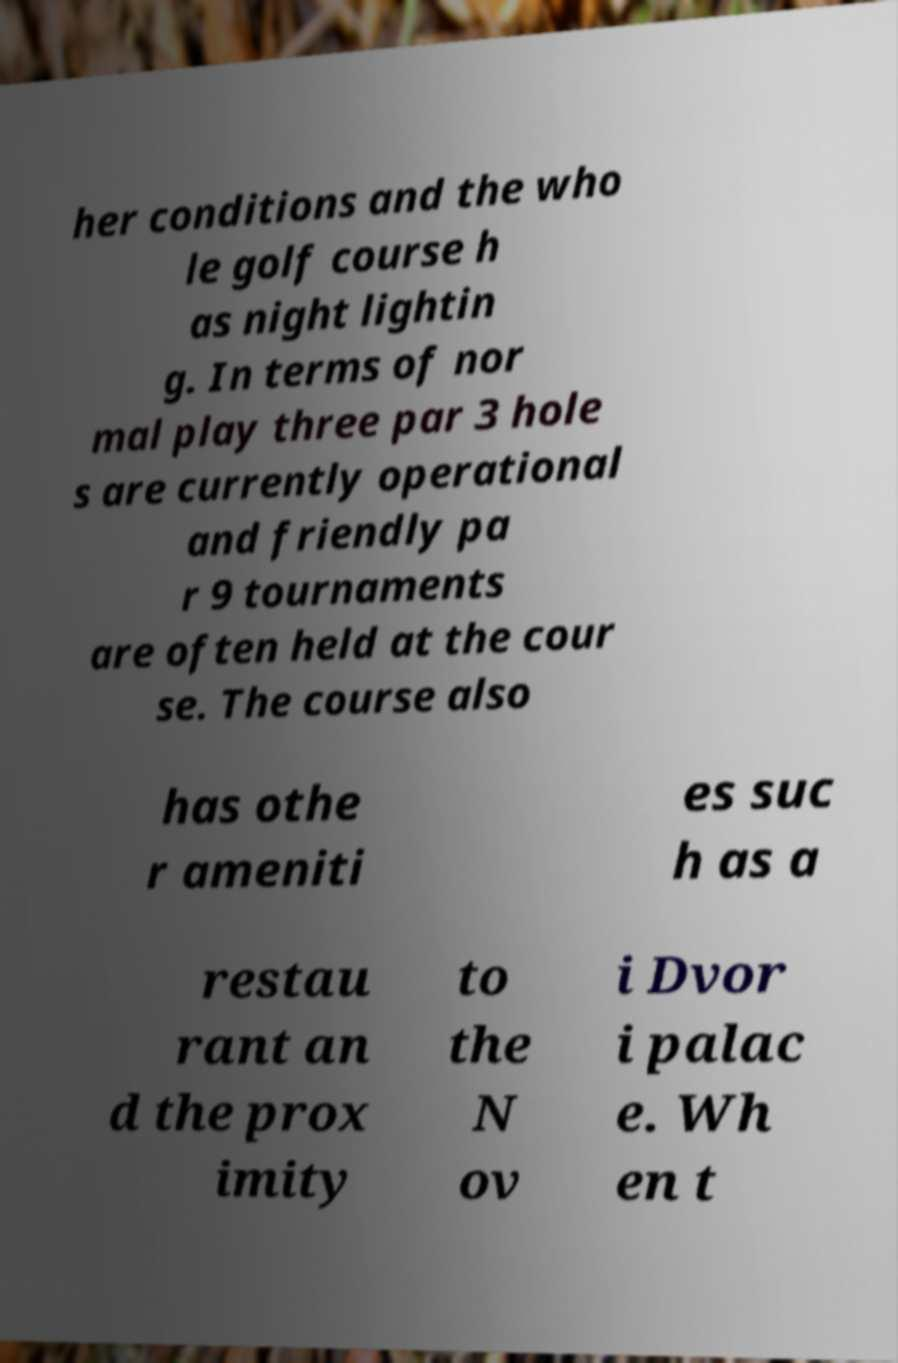Could you assist in decoding the text presented in this image and type it out clearly? her conditions and the who le golf course h as night lightin g. In terms of nor mal play three par 3 hole s are currently operational and friendly pa r 9 tournaments are often held at the cour se. The course also has othe r ameniti es suc h as a restau rant an d the prox imity to the N ov i Dvor i palac e. Wh en t 